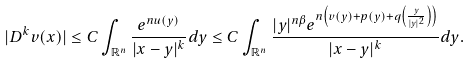Convert formula to latex. <formula><loc_0><loc_0><loc_500><loc_500>| D ^ { k } v ( x ) | \leq C \int _ { \mathbb { R } ^ { n } } \frac { e ^ { n u ( y ) } } { | x - y | ^ { k } } d y \leq C \int _ { \mathbb { R } ^ { n } } \frac { | y | ^ { n \beta } e ^ { n \left ( v ( y ) + p ( y ) + q \left ( \frac { y } { | y | ^ { 2 } } \right ) \right ) } } { | x - y | ^ { k } } d y .</formula> 